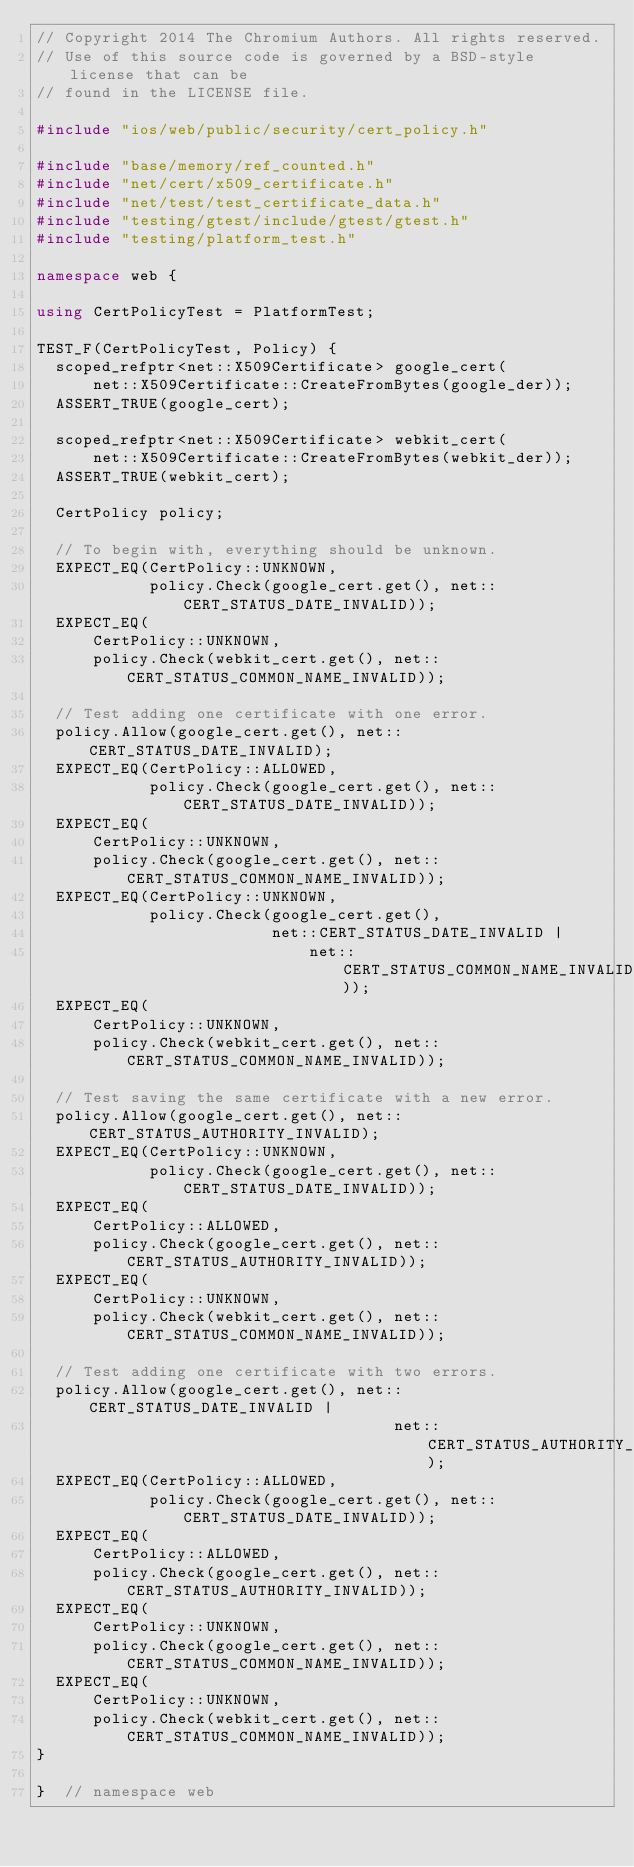<code> <loc_0><loc_0><loc_500><loc_500><_C++_>// Copyright 2014 The Chromium Authors. All rights reserved.
// Use of this source code is governed by a BSD-style license that can be
// found in the LICENSE file.

#include "ios/web/public/security/cert_policy.h"

#include "base/memory/ref_counted.h"
#include "net/cert/x509_certificate.h"
#include "net/test/test_certificate_data.h"
#include "testing/gtest/include/gtest/gtest.h"
#include "testing/platform_test.h"

namespace web {

using CertPolicyTest = PlatformTest;

TEST_F(CertPolicyTest, Policy) {
  scoped_refptr<net::X509Certificate> google_cert(
      net::X509Certificate::CreateFromBytes(google_der));
  ASSERT_TRUE(google_cert);

  scoped_refptr<net::X509Certificate> webkit_cert(
      net::X509Certificate::CreateFromBytes(webkit_der));
  ASSERT_TRUE(webkit_cert);

  CertPolicy policy;

  // To begin with, everything should be unknown.
  EXPECT_EQ(CertPolicy::UNKNOWN,
            policy.Check(google_cert.get(), net::CERT_STATUS_DATE_INVALID));
  EXPECT_EQ(
      CertPolicy::UNKNOWN,
      policy.Check(webkit_cert.get(), net::CERT_STATUS_COMMON_NAME_INVALID));

  // Test adding one certificate with one error.
  policy.Allow(google_cert.get(), net::CERT_STATUS_DATE_INVALID);
  EXPECT_EQ(CertPolicy::ALLOWED,
            policy.Check(google_cert.get(), net::CERT_STATUS_DATE_INVALID));
  EXPECT_EQ(
      CertPolicy::UNKNOWN,
      policy.Check(google_cert.get(), net::CERT_STATUS_COMMON_NAME_INVALID));
  EXPECT_EQ(CertPolicy::UNKNOWN,
            policy.Check(google_cert.get(),
                         net::CERT_STATUS_DATE_INVALID |
                             net::CERT_STATUS_COMMON_NAME_INVALID));
  EXPECT_EQ(
      CertPolicy::UNKNOWN,
      policy.Check(webkit_cert.get(), net::CERT_STATUS_COMMON_NAME_INVALID));

  // Test saving the same certificate with a new error.
  policy.Allow(google_cert.get(), net::CERT_STATUS_AUTHORITY_INVALID);
  EXPECT_EQ(CertPolicy::UNKNOWN,
            policy.Check(google_cert.get(), net::CERT_STATUS_DATE_INVALID));
  EXPECT_EQ(
      CertPolicy::ALLOWED,
      policy.Check(google_cert.get(), net::CERT_STATUS_AUTHORITY_INVALID));
  EXPECT_EQ(
      CertPolicy::UNKNOWN,
      policy.Check(webkit_cert.get(), net::CERT_STATUS_COMMON_NAME_INVALID));

  // Test adding one certificate with two errors.
  policy.Allow(google_cert.get(), net::CERT_STATUS_DATE_INVALID |
                                      net::CERT_STATUS_AUTHORITY_INVALID);
  EXPECT_EQ(CertPolicy::ALLOWED,
            policy.Check(google_cert.get(), net::CERT_STATUS_DATE_INVALID));
  EXPECT_EQ(
      CertPolicy::ALLOWED,
      policy.Check(google_cert.get(), net::CERT_STATUS_AUTHORITY_INVALID));
  EXPECT_EQ(
      CertPolicy::UNKNOWN,
      policy.Check(google_cert.get(), net::CERT_STATUS_COMMON_NAME_INVALID));
  EXPECT_EQ(
      CertPolicy::UNKNOWN,
      policy.Check(webkit_cert.get(), net::CERT_STATUS_COMMON_NAME_INVALID));
}

}  // namespace web
</code> 